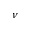Convert formula to latex. <formula><loc_0><loc_0><loc_500><loc_500>\nu</formula> 